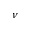Convert formula to latex. <formula><loc_0><loc_0><loc_500><loc_500>\nu</formula> 